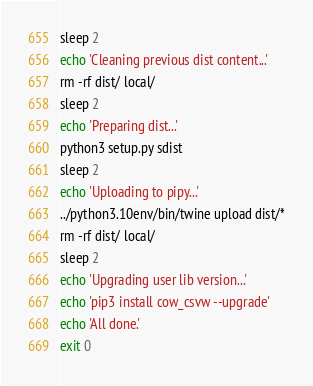<code> <loc_0><loc_0><loc_500><loc_500><_Bash_>sleep 2
echo 'Cleaning previous dist content...'
rm -rf dist/ local/
sleep 2
echo 'Preparing dist...'
python3 setup.py sdist
sleep 2
echo 'Uploading to pipy...'
../python3.10env/bin/twine upload dist/*
rm -rf dist/ local/
sleep 2
echo 'Upgrading user lib version...'
echo 'pip3 install cow_csvw --upgrade'
echo 'All done.'
exit 0
</code> 